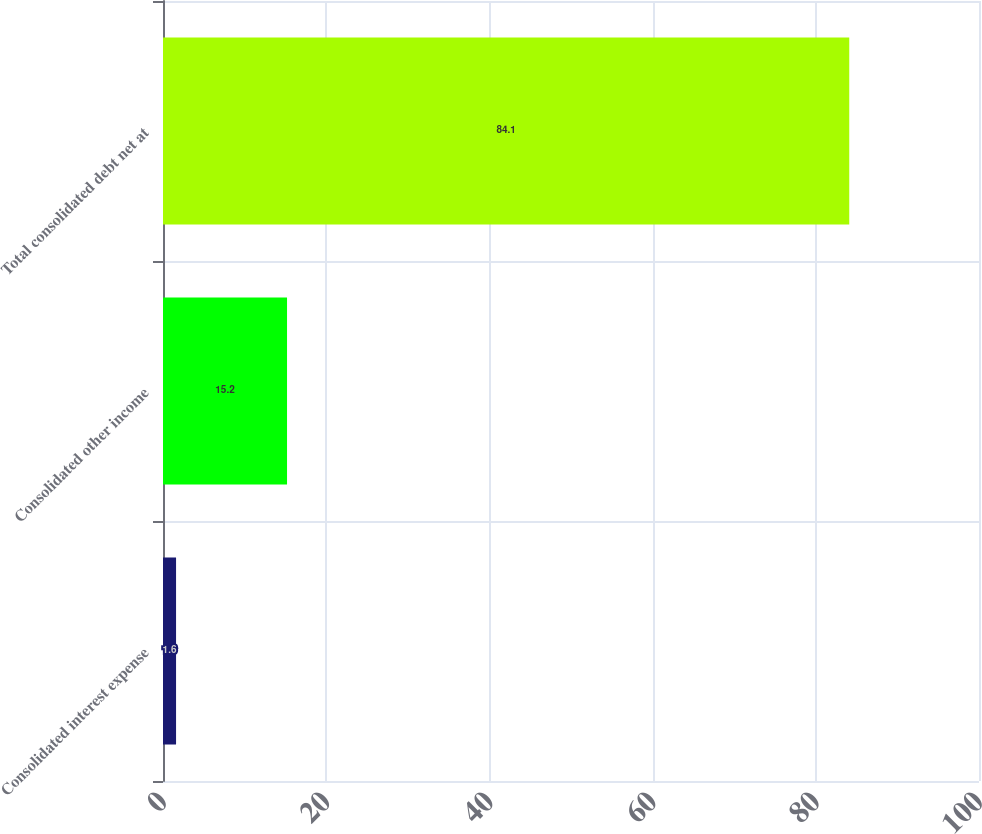Convert chart. <chart><loc_0><loc_0><loc_500><loc_500><bar_chart><fcel>Consolidated interest expense<fcel>Consolidated other income<fcel>Total consolidated debt net at<nl><fcel>1.6<fcel>15.2<fcel>84.1<nl></chart> 